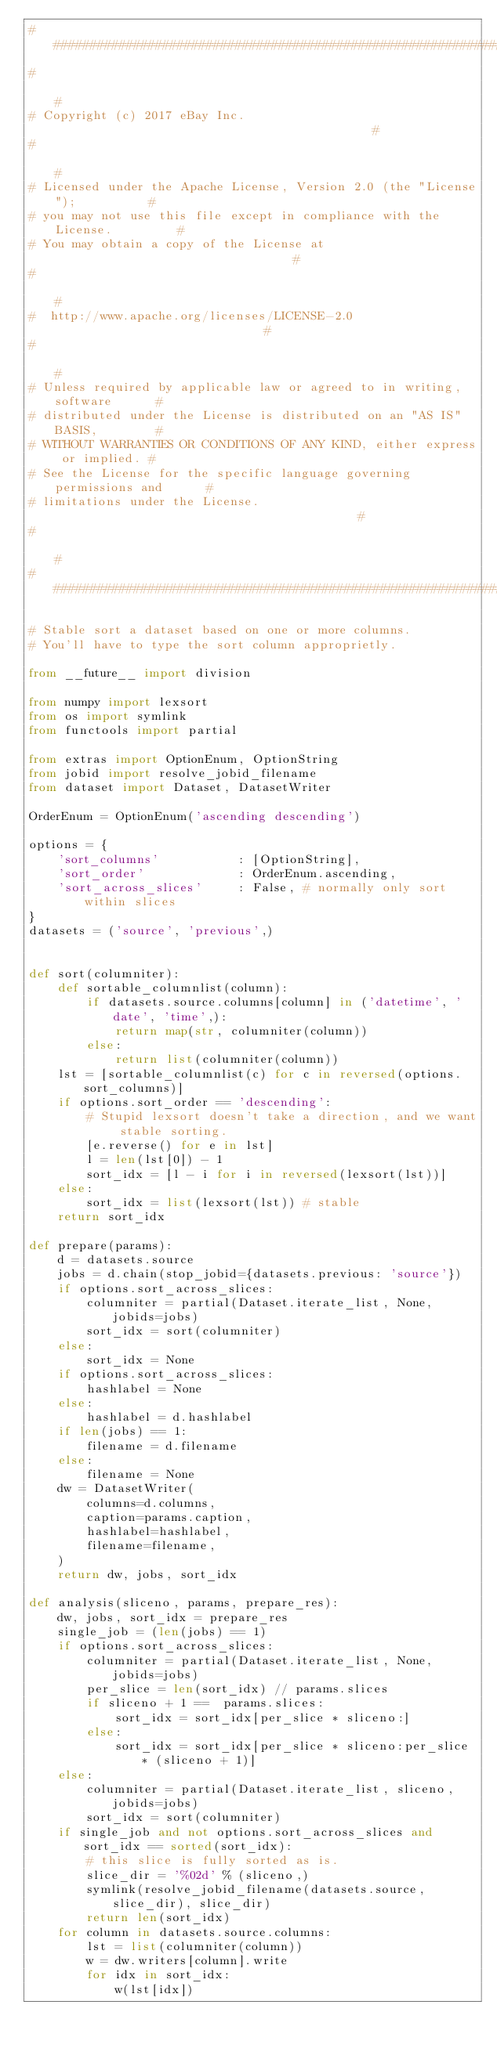<code> <loc_0><loc_0><loc_500><loc_500><_Python_>############################################################################
#                                                                          #
# Copyright (c) 2017 eBay Inc.                                             #
#                                                                          #
# Licensed under the Apache License, Version 2.0 (the "License");          #
# you may not use this file except in compliance with the License.         #
# You may obtain a copy of the License at                                  #
#                                                                          #
#  http://www.apache.org/licenses/LICENSE-2.0                              #
#                                                                          #
# Unless required by applicable law or agreed to in writing, software      #
# distributed under the License is distributed on an "AS IS" BASIS,        #
# WITHOUT WARRANTIES OR CONDITIONS OF ANY KIND, either express or implied. #
# See the License for the specific language governing permissions and      #
# limitations under the License.                                           #
#                                                                          #
############################################################################

# Stable sort a dataset based on one or more columns.
# You'll have to type the sort column approprietly.

from __future__ import division

from numpy import lexsort
from os import symlink
from functools import partial

from extras import OptionEnum, OptionString
from jobid import resolve_jobid_filename
from dataset import Dataset, DatasetWriter

OrderEnum = OptionEnum('ascending descending')

options = {
	'sort_columns'           : [OptionString],
	'sort_order'             : OrderEnum.ascending,
	'sort_across_slices'     : False, # normally only sort within slices
}
datasets = ('source', 'previous',)


def sort(columniter):
	def sortable_columnlist(column):
		if datasets.source.columns[column] in ('datetime', 'date', 'time',):
			return map(str, columniter(column))
		else:
			return list(columniter(column))
	lst = [sortable_columnlist(c) for c in reversed(options.sort_columns)]
	if options.sort_order == 'descending':
		# Stupid lexsort doesn't take a direction, and we want stable sorting.
		[e.reverse() for e in lst]
		l = len(lst[0]) - 1
		sort_idx = [l - i for i in reversed(lexsort(lst))]
	else:
		sort_idx = list(lexsort(lst)) # stable
	return sort_idx

def prepare(params):
	d = datasets.source
	jobs = d.chain(stop_jobid={datasets.previous: 'source'})
	if options.sort_across_slices:
		columniter = partial(Dataset.iterate_list, None, jobids=jobs)
		sort_idx = sort(columniter)
	else:
		sort_idx = None
	if options.sort_across_slices:
		hashlabel = None
	else:
		hashlabel = d.hashlabel
	if len(jobs) == 1:
		filename = d.filename
	else:
		filename = None
	dw = DatasetWriter(
		columns=d.columns,
		caption=params.caption,
		hashlabel=hashlabel,
		filename=filename,
	)
	return dw, jobs, sort_idx

def analysis(sliceno, params, prepare_res):
	dw, jobs, sort_idx = prepare_res
	single_job = (len(jobs) == 1)
	if options.sort_across_slices:
		columniter = partial(Dataset.iterate_list, None, jobids=jobs)
		per_slice = len(sort_idx) // params.slices
		if sliceno + 1 ==  params.slices:
			sort_idx = sort_idx[per_slice * sliceno:]
		else:
			sort_idx = sort_idx[per_slice * sliceno:per_slice * (sliceno + 1)]
	else:
		columniter = partial(Dataset.iterate_list, sliceno, jobids=jobs)
		sort_idx = sort(columniter)
	if single_job and not options.sort_across_slices and sort_idx == sorted(sort_idx):
		# this slice is fully sorted as is.
		slice_dir = '%02d' % (sliceno,)
		symlink(resolve_jobid_filename(datasets.source, slice_dir), slice_dir)
		return len(sort_idx)
	for column in datasets.source.columns:
		lst = list(columniter(column))
		w = dw.writers[column].write
		for idx in sort_idx:
			w(lst[idx])
</code> 